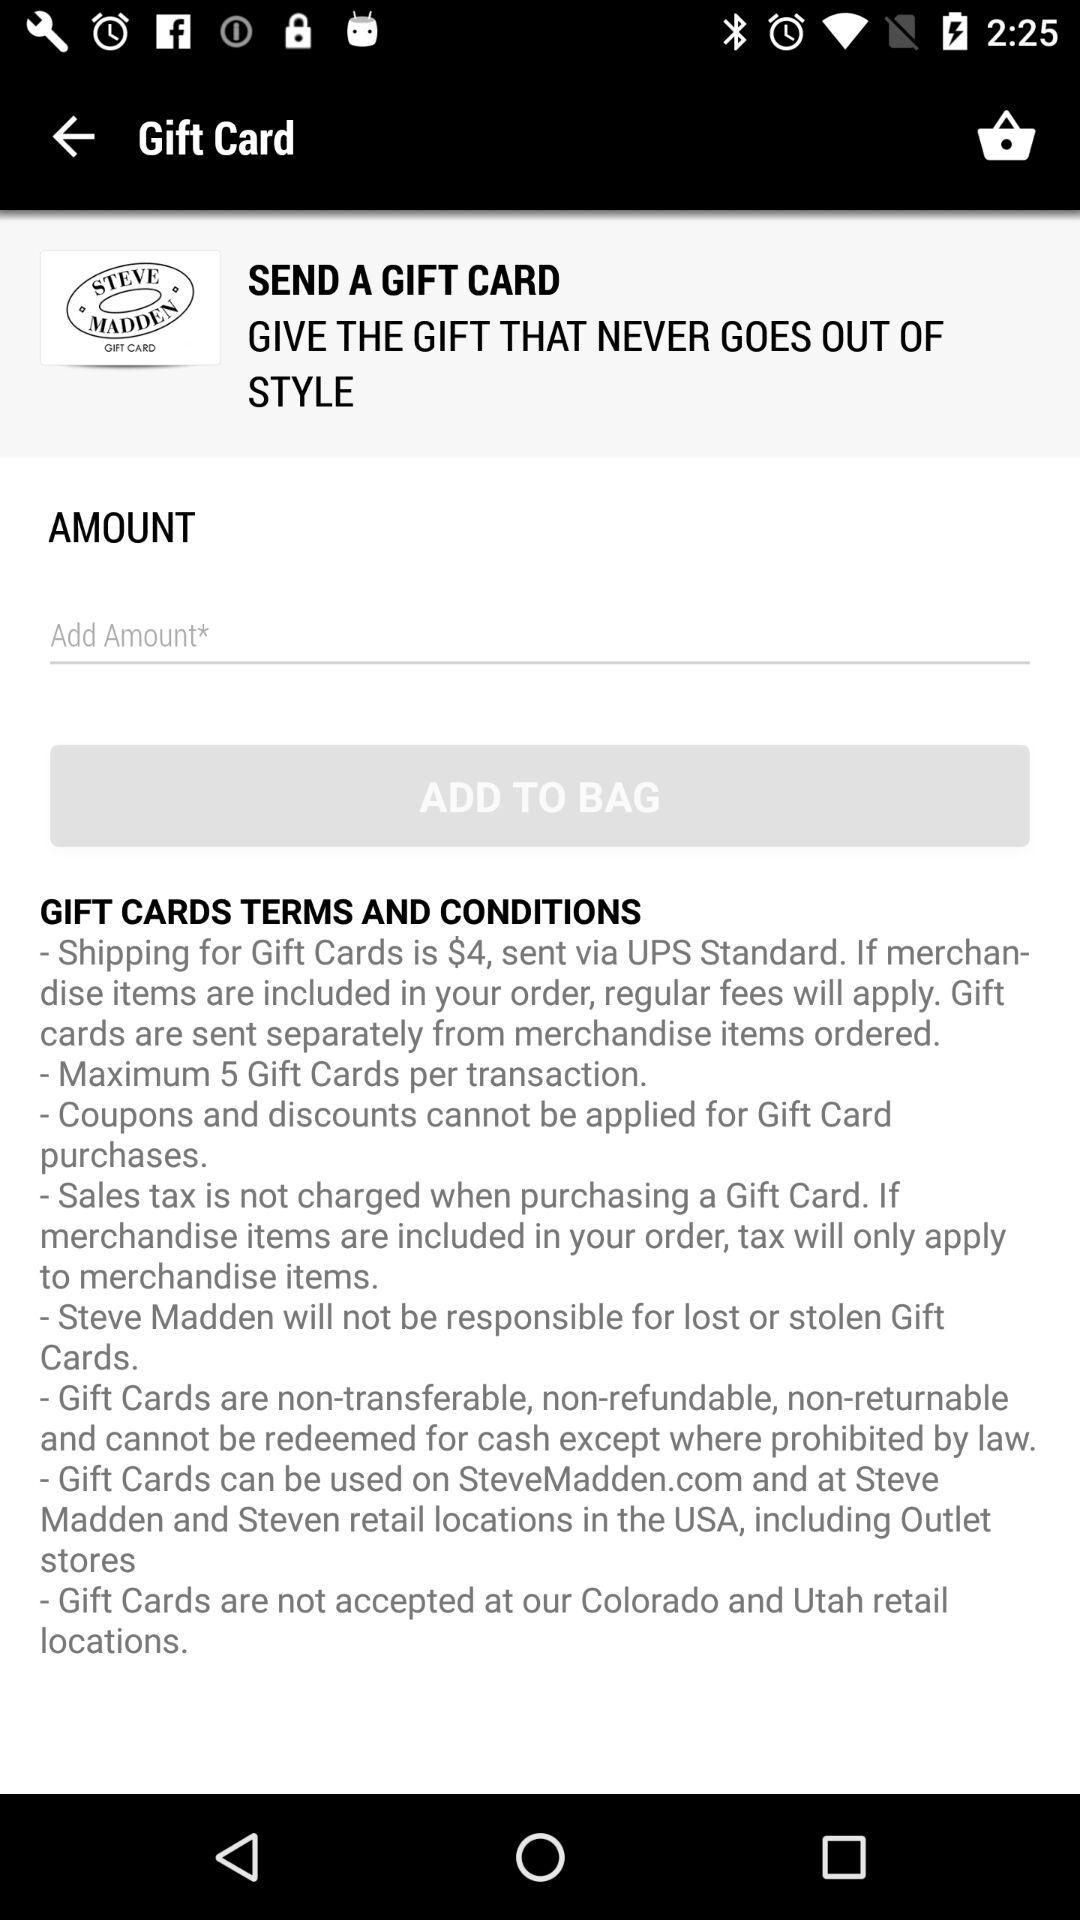What is the maximum number of gift cards that can be purchased at once?
Answer the question using a single word or phrase. 5 